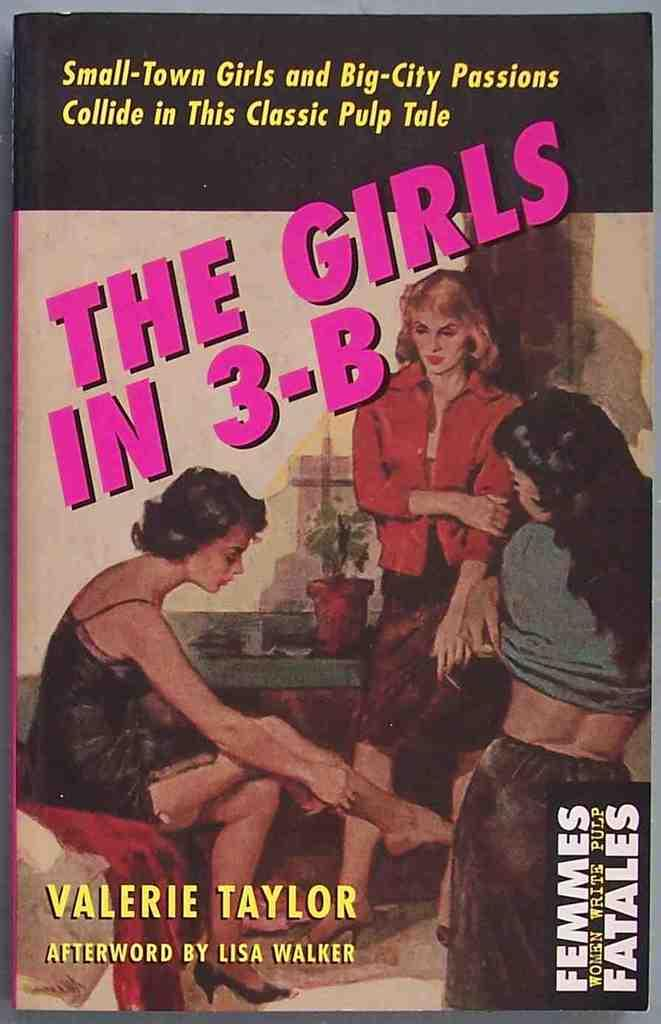<image>
Write a terse but informative summary of the picture. A front cover for a book called "The girls in 3-B". 